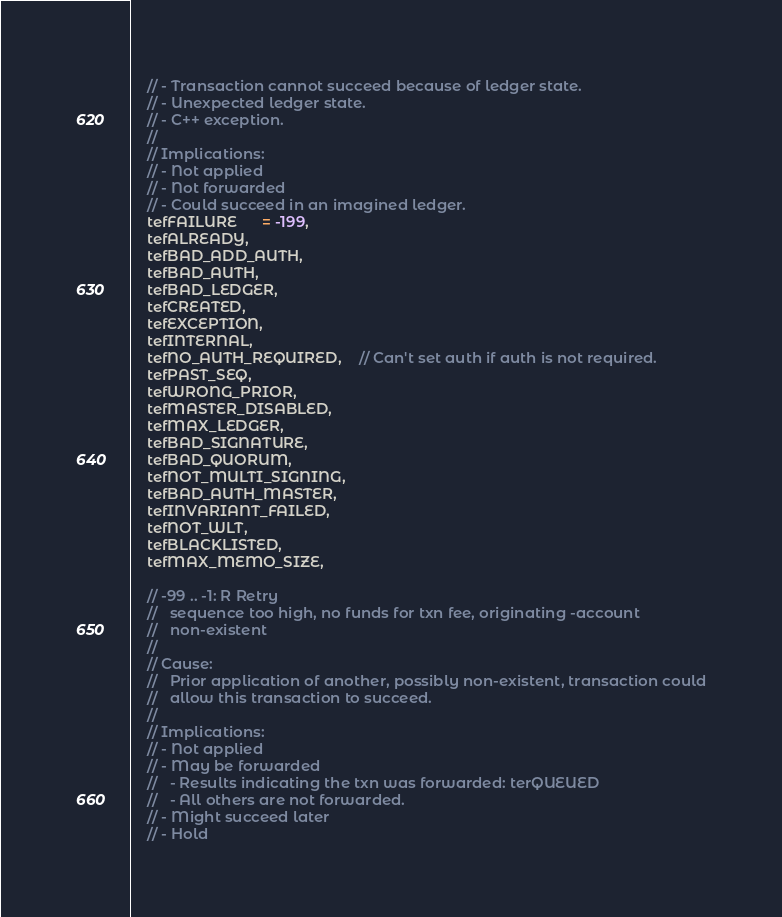<code> <loc_0><loc_0><loc_500><loc_500><_C_>    // - Transaction cannot succeed because of ledger state.
    // - Unexpected ledger state.
    // - C++ exception.
    //
    // Implications:
    // - Not applied
    // - Not forwarded
    // - Could succeed in an imagined ledger.
    tefFAILURE      = -199,
    tefALREADY,
    tefBAD_ADD_AUTH,
    tefBAD_AUTH,
    tefBAD_LEDGER,
    tefCREATED,
    tefEXCEPTION,
    tefINTERNAL,
    tefNO_AUTH_REQUIRED,    // Can't set auth if auth is not required.
    tefPAST_SEQ,
    tefWRONG_PRIOR,
    tefMASTER_DISABLED,
    tefMAX_LEDGER,
    tefBAD_SIGNATURE,
    tefBAD_QUORUM,
    tefNOT_MULTI_SIGNING,
    tefBAD_AUTH_MASTER,
    tefINVARIANT_FAILED,
    tefNOT_WLT,
    tefBLACKLISTED,
    tefMAX_MEMO_SIZE,

    // -99 .. -1: R Retry
    //   sequence too high, no funds for txn fee, originating -account
    //   non-existent
    //
    // Cause:
    //   Prior application of another, possibly non-existent, transaction could
    //   allow this transaction to succeed.
    //
    // Implications:
    // - Not applied
    // - May be forwarded
    //   - Results indicating the txn was forwarded: terQUEUED
    //   - All others are not forwarded.
    // - Might succeed later
    // - Hold</code> 